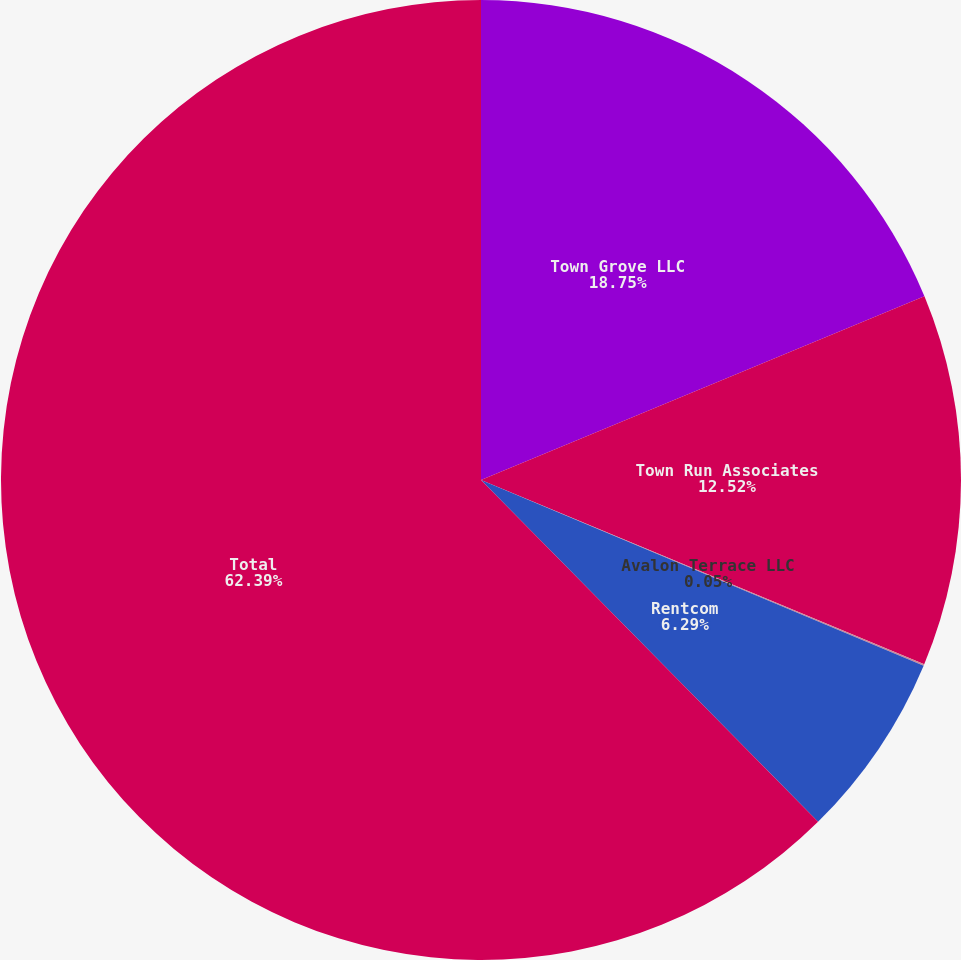<chart> <loc_0><loc_0><loc_500><loc_500><pie_chart><fcel>Town Grove LLC<fcel>Town Run Associates<fcel>Avalon Terrace LLC<fcel>Rentcom<fcel>Total<nl><fcel>18.75%<fcel>12.52%<fcel>0.05%<fcel>6.29%<fcel>62.39%<nl></chart> 